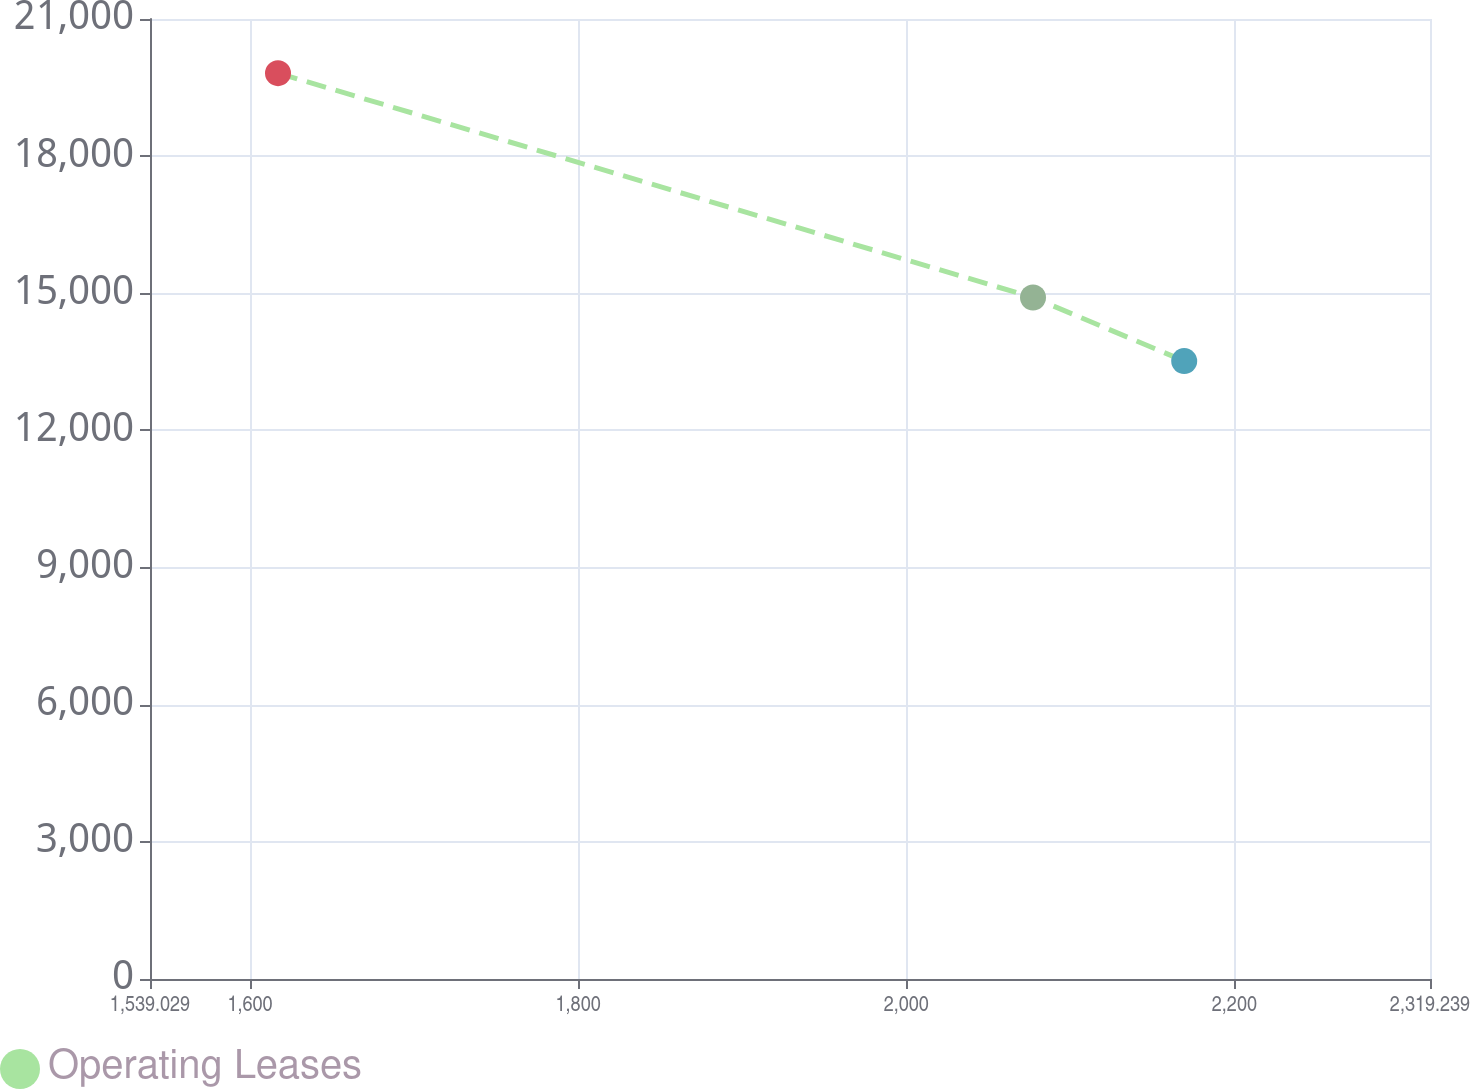Convert chart. <chart><loc_0><loc_0><loc_500><loc_500><line_chart><ecel><fcel>Operating Leases<nl><fcel>1617.05<fcel>19815.8<nl><fcel>2077.26<fcel>14908.2<nl><fcel>2169.42<fcel>13517.2<nl><fcel>2397.26<fcel>14147<nl></chart> 